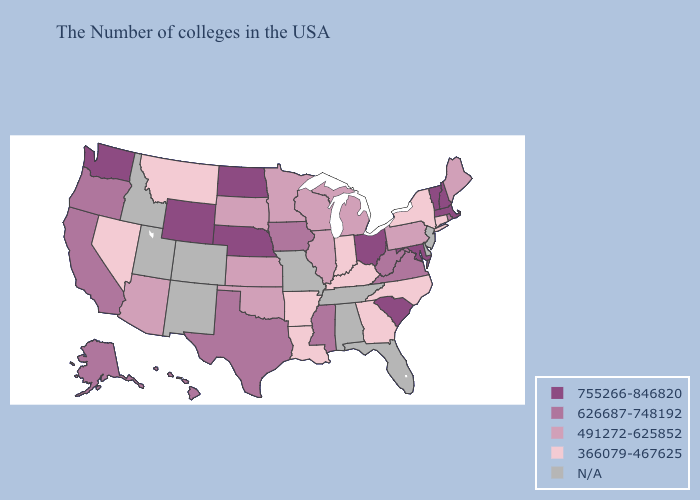Name the states that have a value in the range 626687-748192?
Quick response, please. Rhode Island, Virginia, West Virginia, Mississippi, Iowa, Texas, California, Oregon, Alaska, Hawaii. Does Washington have the lowest value in the USA?
Be succinct. No. Among the states that border Kansas , does Oklahoma have the highest value?
Answer briefly. No. Does the map have missing data?
Concise answer only. Yes. Does the first symbol in the legend represent the smallest category?
Quick response, please. No. Name the states that have a value in the range 626687-748192?
Keep it brief. Rhode Island, Virginia, West Virginia, Mississippi, Iowa, Texas, California, Oregon, Alaska, Hawaii. What is the value of Nebraska?
Quick response, please. 755266-846820. Does the map have missing data?
Give a very brief answer. Yes. Name the states that have a value in the range 366079-467625?
Short answer required. Connecticut, New York, North Carolina, Georgia, Kentucky, Indiana, Louisiana, Arkansas, Montana, Nevada. Does Nevada have the lowest value in the West?
Write a very short answer. Yes. What is the lowest value in the South?
Concise answer only. 366079-467625. What is the value of Georgia?
Answer briefly. 366079-467625. Which states have the lowest value in the West?
Give a very brief answer. Montana, Nevada. 